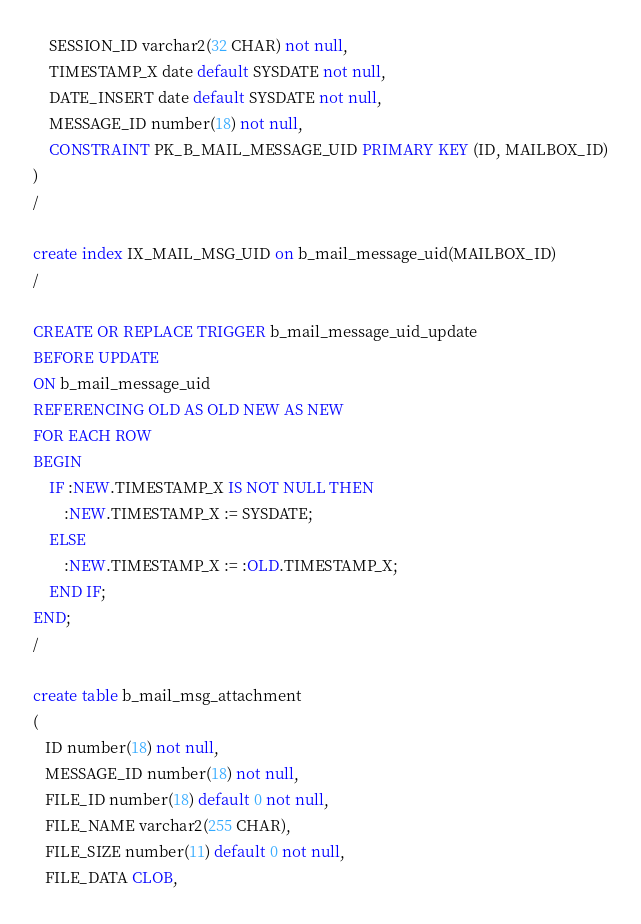<code> <loc_0><loc_0><loc_500><loc_500><_SQL_>	SESSION_ID varchar2(32 CHAR) not null,
	TIMESTAMP_X date default SYSDATE not null,
	DATE_INSERT date default SYSDATE not null,
	MESSAGE_ID number(18) not null,
	CONSTRAINT PK_B_MAIL_MESSAGE_UID PRIMARY KEY (ID, MAILBOX_ID)
)
/

create index IX_MAIL_MSG_UID on b_mail_message_uid(MAILBOX_ID)
/

CREATE OR REPLACE TRIGGER b_mail_message_uid_update
BEFORE UPDATE 
ON b_mail_message_uid
REFERENCING OLD AS OLD NEW AS NEW
FOR EACH ROW 
BEGIN
	IF :NEW.TIMESTAMP_X IS NOT NULL THEN
		:NEW.TIMESTAMP_X := SYSDATE;
	ELSE
		:NEW.TIMESTAMP_X := :OLD.TIMESTAMP_X;
	END IF;
END;
/

create table b_mail_msg_attachment 
(
   ID number(18) not null,
   MESSAGE_ID number(18) not null,
   FILE_ID number(18) default 0 not null,
   FILE_NAME varchar2(255 CHAR),
   FILE_SIZE number(11) default 0 not null,
   FILE_DATA CLOB,</code> 